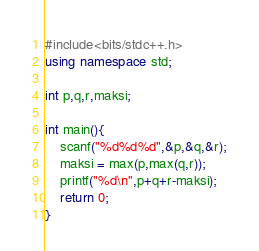<code> <loc_0><loc_0><loc_500><loc_500><_C++_>#include<bits/stdc++.h>
using namespace std;

int p,q,r,maksi;

int main(){
	scanf("%d%d%d",&p,&q,&r);
	maksi = max(p,max(q,r));
	printf("%d\n",p+q+r-maksi);
	return 0;
}</code> 